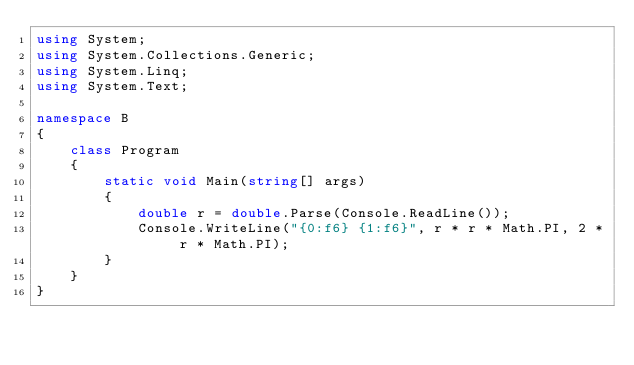Convert code to text. <code><loc_0><loc_0><loc_500><loc_500><_C#_>using System;
using System.Collections.Generic;
using System.Linq;
using System.Text;

namespace B
{
    class Program
    {
        static void Main(string[] args)
        {
            double r = double.Parse(Console.ReadLine());
            Console.WriteLine("{0:f6} {1:f6}", r * r * Math.PI, 2 * r * Math.PI);
        }
    }
}</code> 